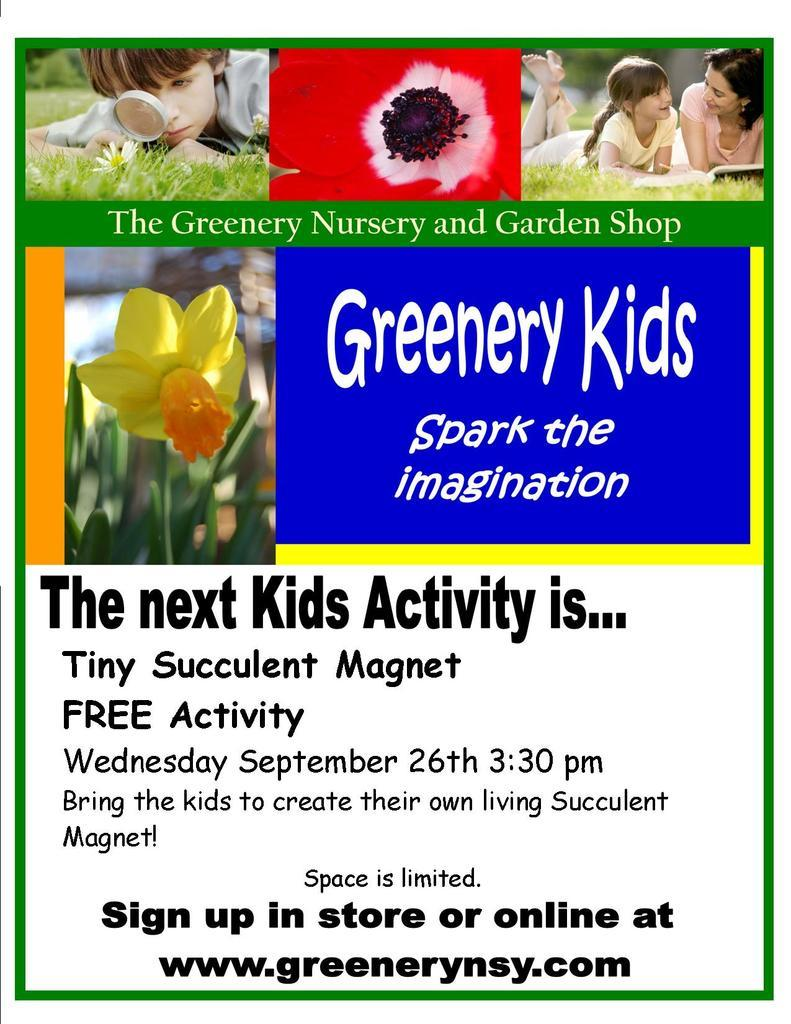What type of visual is the image? The image is a poster. What can be seen in the poster besides the people lying on the grass? There is a yellow flower in the poster. What are the people in the poster doing? A boy and two girls are lying on the grass in the poster. Is there any text present in the poster? Yes, there is text written at the bottom of the poster. How many spiders are crawling on the boy's face in the poster? There are no spiders present in the image; it features a boy and two girls lying on the grass with a yellow flower. What type of queen is depicted in the poster? There is no queen depicted in the poster; it features a boy and two girls lying on the grass with a yellow flower. 